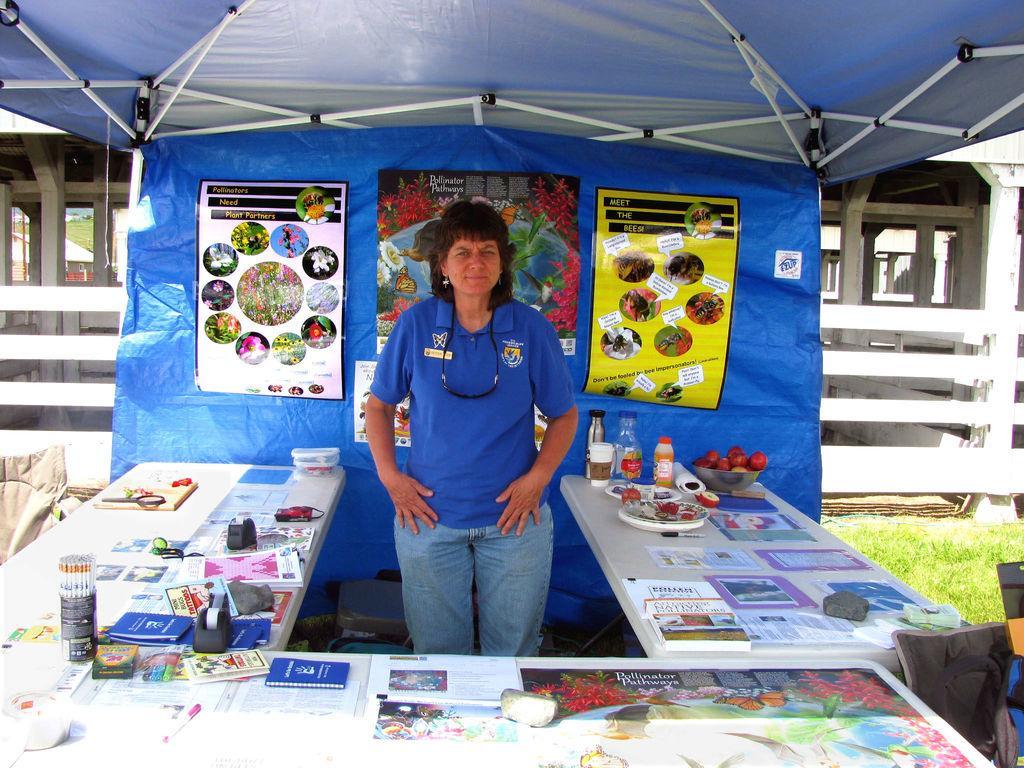Describe this image in one or two sentences. In this image I can see the blue colored tent, few banners attached to the tent, a person wearing blue colored dress is standing and I can see few tables around her. On the tables I can see few books, few papers, few bottles, a plate and few other objects. In the background I can see some grass on the ground and the building. 